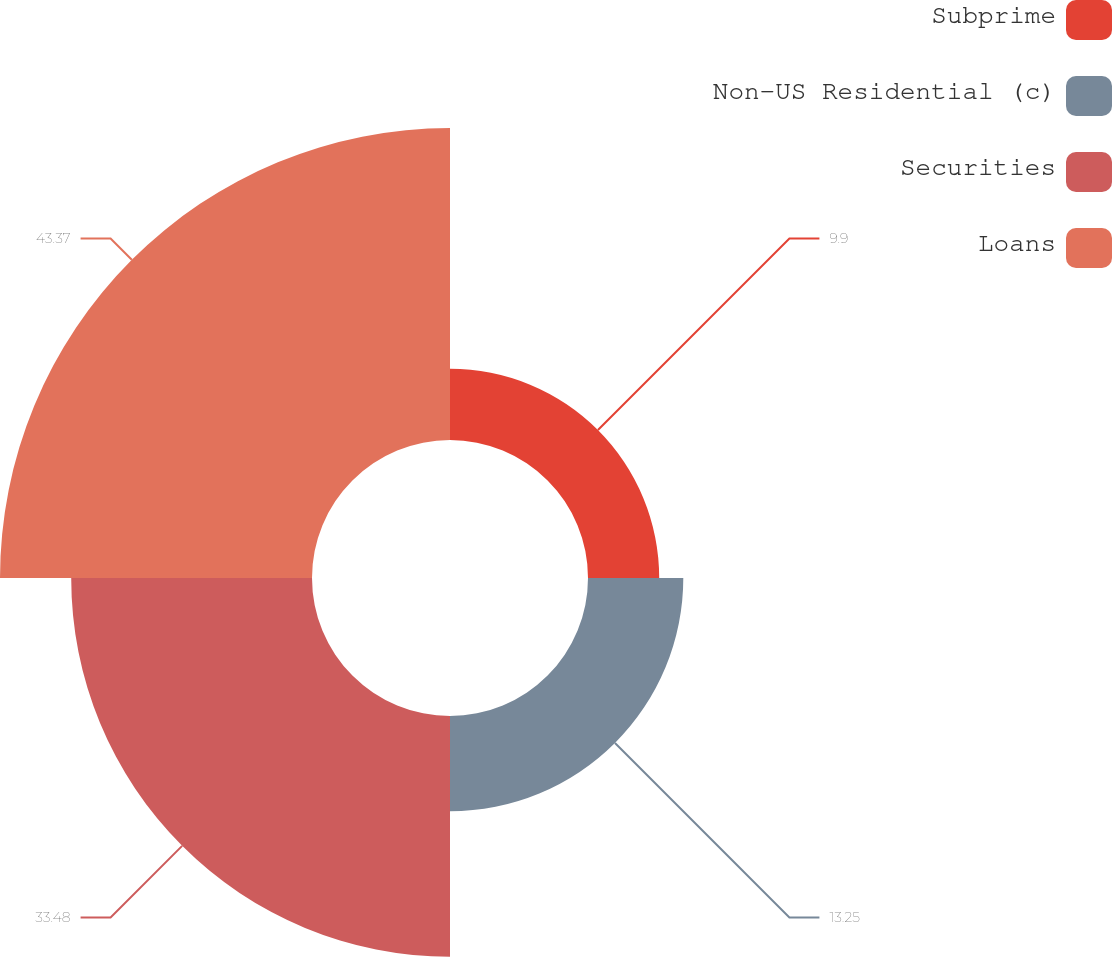Convert chart to OTSL. <chart><loc_0><loc_0><loc_500><loc_500><pie_chart><fcel>Subprime<fcel>Non-US Residential (c)<fcel>Securities<fcel>Loans<nl><fcel>9.9%<fcel>13.25%<fcel>33.48%<fcel>43.38%<nl></chart> 